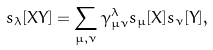Convert formula to latex. <formula><loc_0><loc_0><loc_500><loc_500>s _ { \lambda } [ X Y ] = \sum _ { \mu , \nu } \gamma ^ { \lambda } _ { { \mu } { \nu } } s _ { \mu } [ X ] s _ { \nu } [ Y ] ,</formula> 